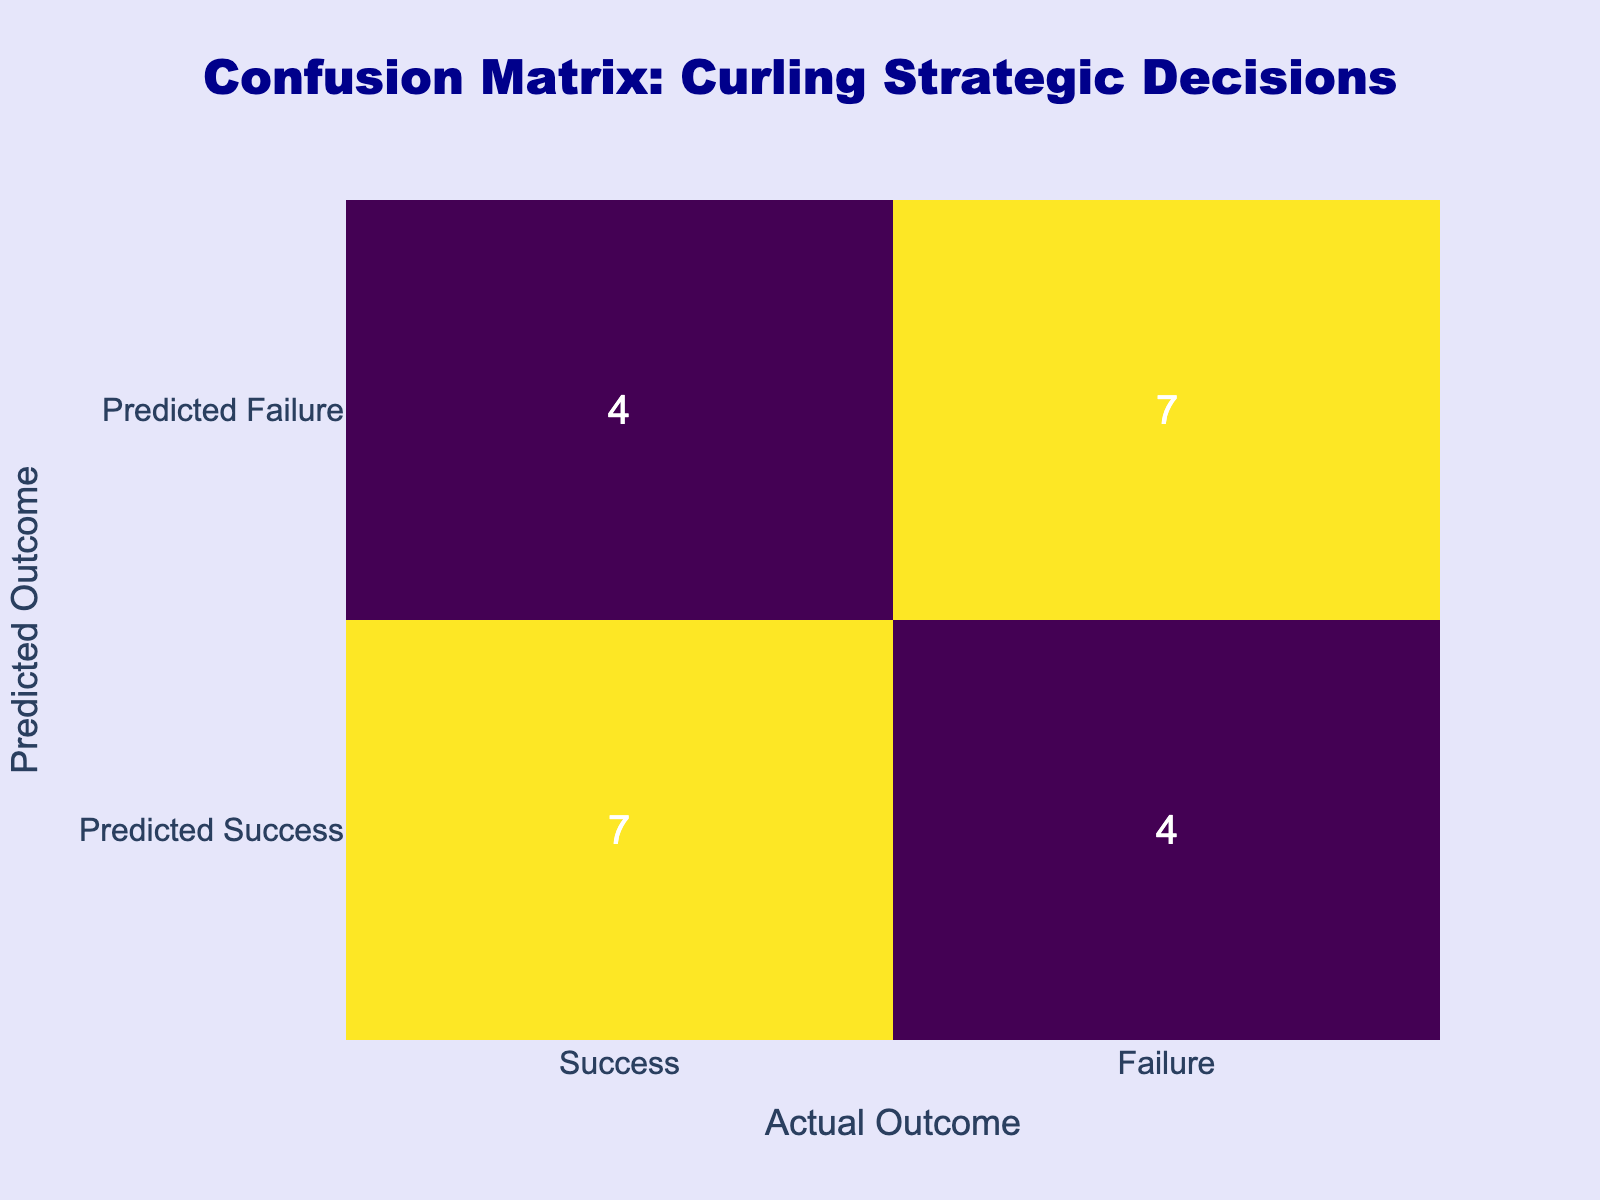What is the number of successful aggressive takeout strategies? According to the table, the aggressive takeout strategy had 1 success and 0 failures. Therefore, the number of successful aggressive takeout strategies is 1.
Answer: 1 How many total failures resulted from defensive guard strategies? The defensive guard strategy had 1 success and 1 failure. Thus, the total failures from defensive guard strategies is 1.
Answer: 1 What is the total number of successful strategies listed in the table? By adding the successes from each strategy: 1 (Aggressive Takeout) + 1 (Defensive Guard) + 1 (Center Line Draw) + 1 (Last Stone Advantage) + 1 (Rock Placement for End) + 1 (Power Play) + 1 (Endgame Strategy) = 7 successes in total.
Answer: 7 Are there any strategies that resulted in both success and failure? The defensive guard strategy is the only one that resulted in a success (1) and a failure (1), making it the only strategy with both outcomes.
Answer: Yes Which had a higher failure rate: open hit or steal tactics? The open hit strategy had 1 failure and 0 successes, while the steal tactics had 1 failure and 0 successes as well. Although their failure rates are the same, they are both equally high.
Answer: They are equal What is the overall success rate for the strategies listed? To find the overall success rate, calculate the total number of successes (7) divided by the total outcomes (successes + failures = 7 + 5 = 12), resulting in a success rate of 7/12 which approximates to 58.33%.
Answer: Approximately 58.33% What is the difference between successful and failed defensive strategies? The only defensive strategy (Defensive Guard) had 1 success and 1 failure. Thus, the difference in successful versus failed defensive strategies is 1 - 1 = 0.
Answer: 0 How many strategies resulted in success but predicted as failure? Analyzing the table, the strategies of aggressive takeout, center line draw, last stone advantage, rock placement for end, power play, and endgame strategy resulted in success but were not predicted as failure. This gives a total of 6 strategies.
Answer: 6 What percentage of the strategies listed had no failures at all? Of the 10 strategies listed, 6 strategies had no failures (Aggressive Takeout, Center Line Draw, Last Stone Advantage, Rock Placement for End, Power Play, Endgame Strategy). Therefore, the percentage is (6/10) * 100 = 60%.
Answer: 60% 